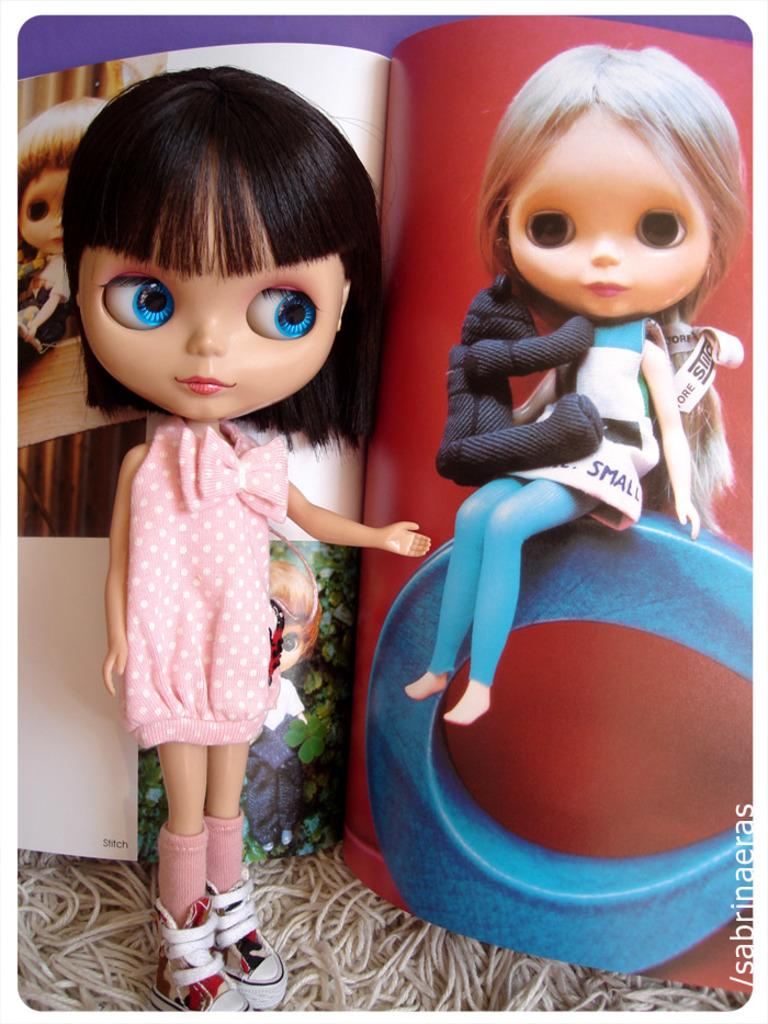What is the main subject in the front of the image? There is a doll in the front of the image. What can be seen in the background of the image? There is a book in the background of the image. What is the content of the book? The book contains images of dolls. What type of canvas is the man painting in the image? There is no man or canvas present in the image. 